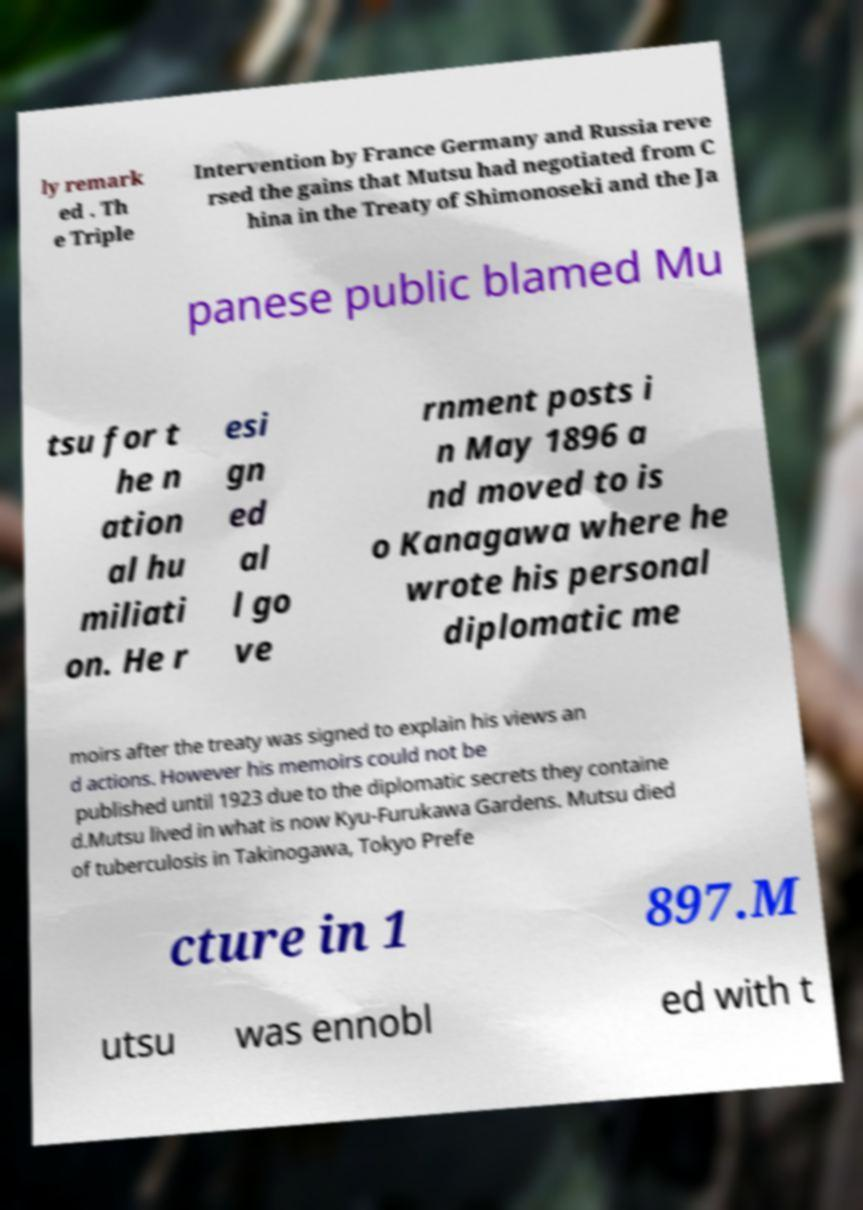There's text embedded in this image that I need extracted. Can you transcribe it verbatim? ly remark ed . Th e Triple Intervention by France Germany and Russia reve rsed the gains that Mutsu had negotiated from C hina in the Treaty of Shimonoseki and the Ja panese public blamed Mu tsu for t he n ation al hu miliati on. He r esi gn ed al l go ve rnment posts i n May 1896 a nd moved to is o Kanagawa where he wrote his personal diplomatic me moirs after the treaty was signed to explain his views an d actions. However his memoirs could not be published until 1923 due to the diplomatic secrets they containe d.Mutsu lived in what is now Kyu-Furukawa Gardens. Mutsu died of tuberculosis in Takinogawa, Tokyo Prefe cture in 1 897.M utsu was ennobl ed with t 